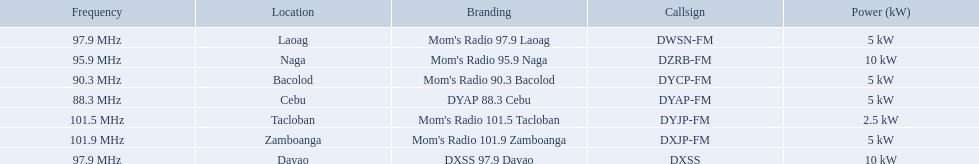What are all of the frequencies? 97.9 MHz, 95.9 MHz, 90.3 MHz, 88.3 MHz, 101.5 MHz, 101.9 MHz, 97.9 MHz. Which of these frequencies is the lowest? 88.3 MHz. Which branding does this frequency belong to? DYAP 88.3 Cebu. 